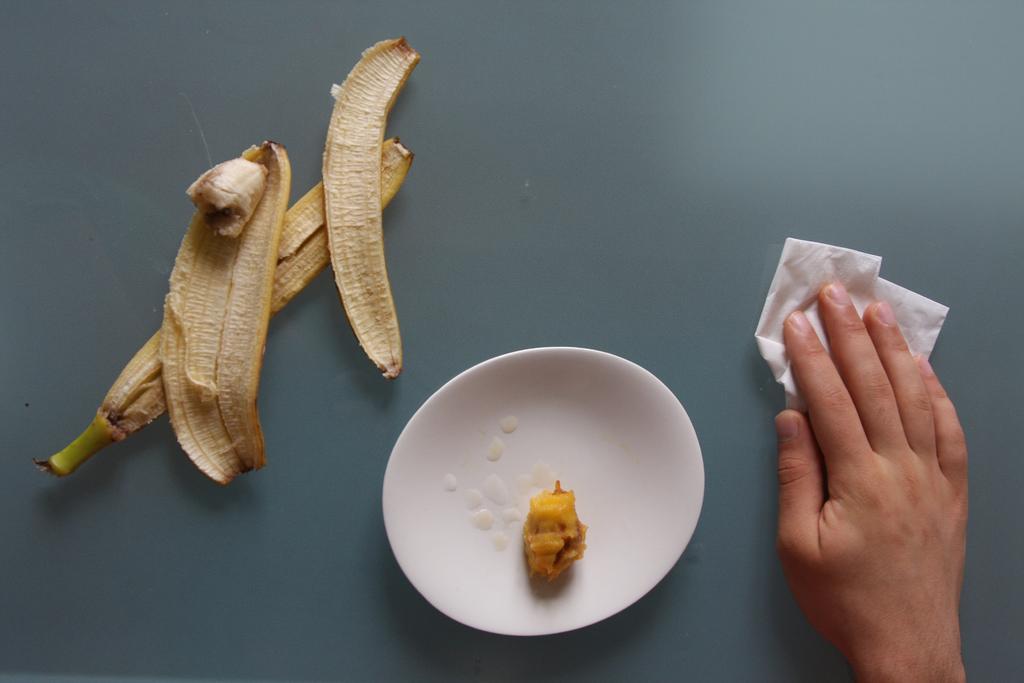In one or two sentences, can you explain what this image depicts? In this image there is a table and we can see a person's hand holding a napkin and cleaning a table. We can see banana peels and there is a plate containing food. 